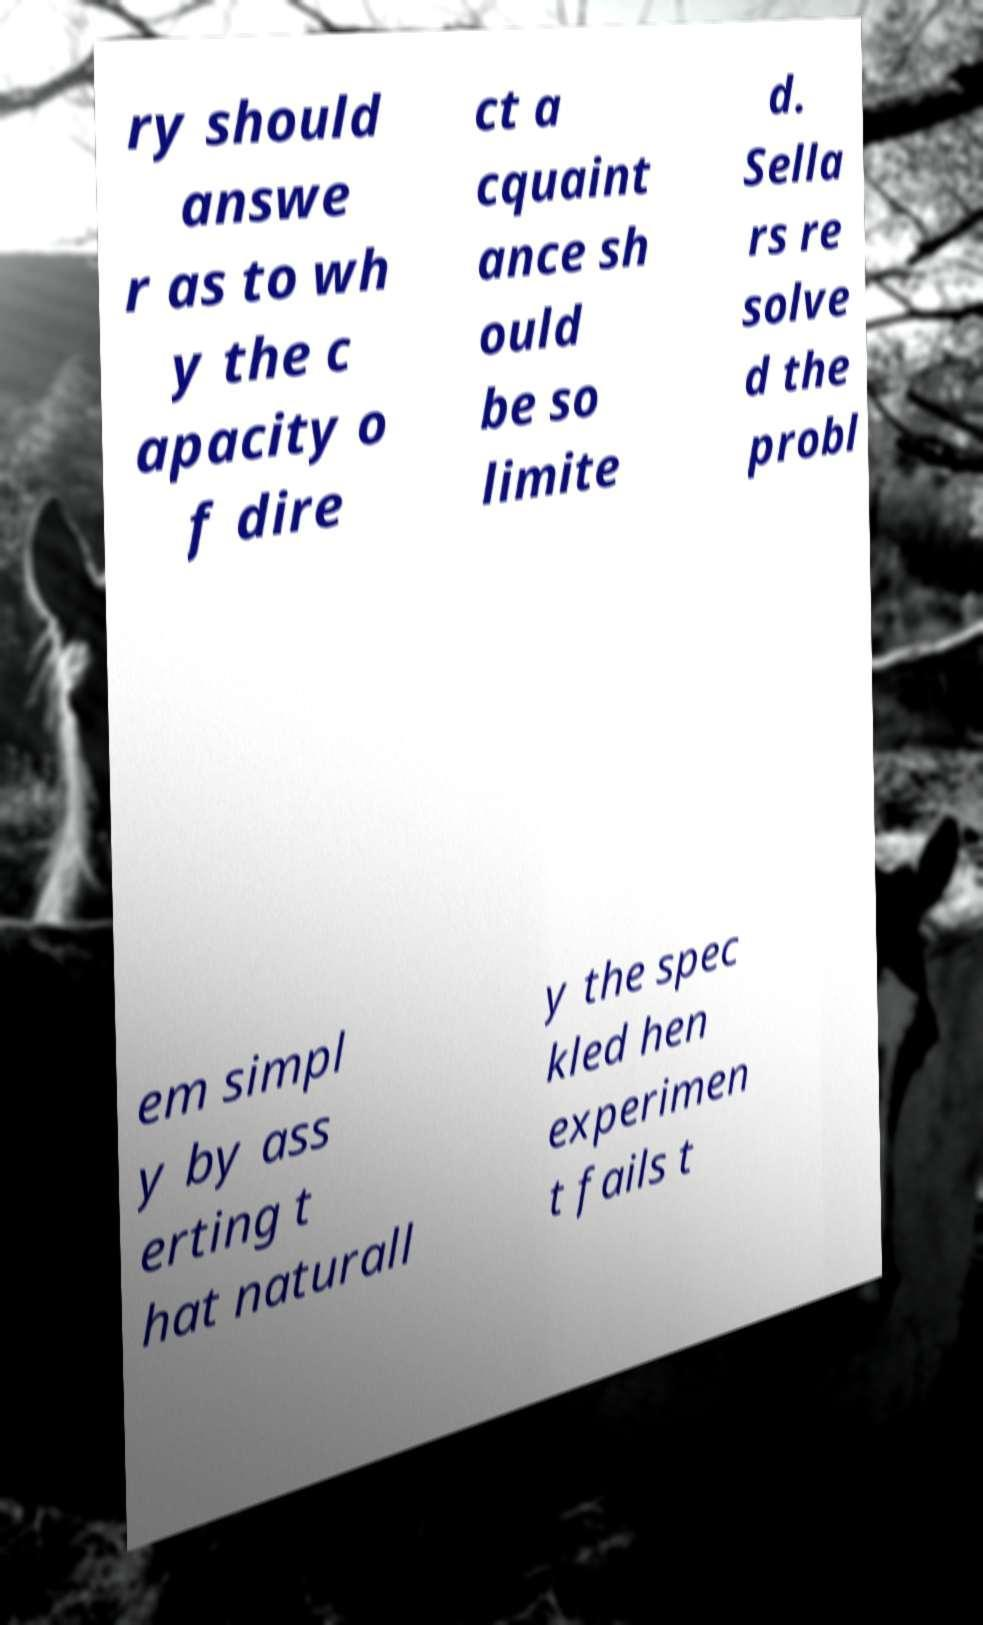Can you accurately transcribe the text from the provided image for me? ry should answe r as to wh y the c apacity o f dire ct a cquaint ance sh ould be so limite d. Sella rs re solve d the probl em simpl y by ass erting t hat naturall y the spec kled hen experimen t fails t 